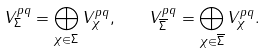Convert formula to latex. <formula><loc_0><loc_0><loc_500><loc_500>V _ { \Sigma } ^ { p q } = \bigoplus _ { \chi \in \Sigma } V _ { \chi } ^ { p q } , \quad V _ { \overline { \Sigma } } ^ { p q } = \bigoplus _ { \chi \in \overline { \Sigma } } V _ { \chi } ^ { p q } .</formula> 